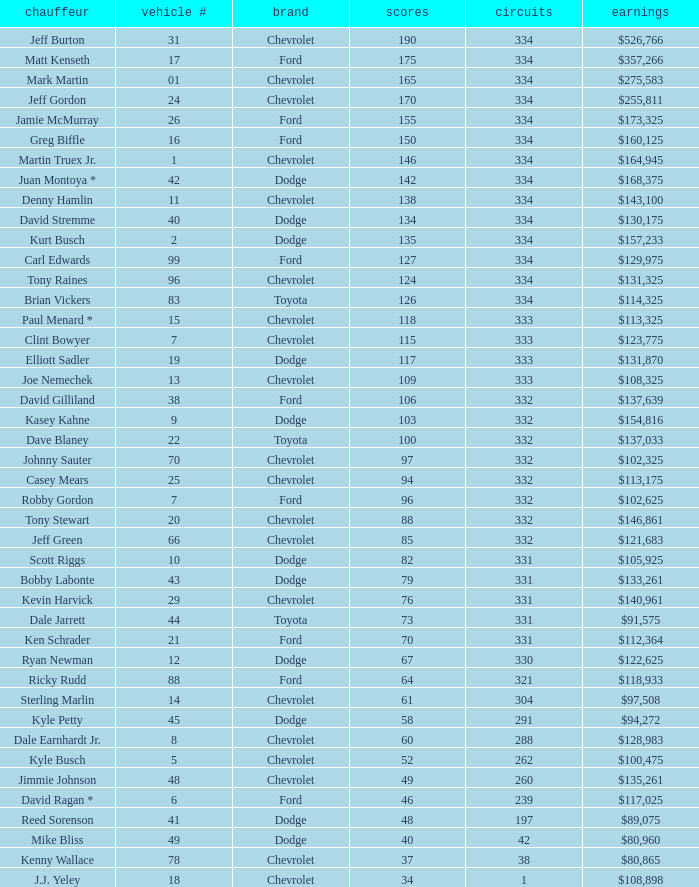How many total laps did the Chevrolet that won $97,508 make? 1.0. 